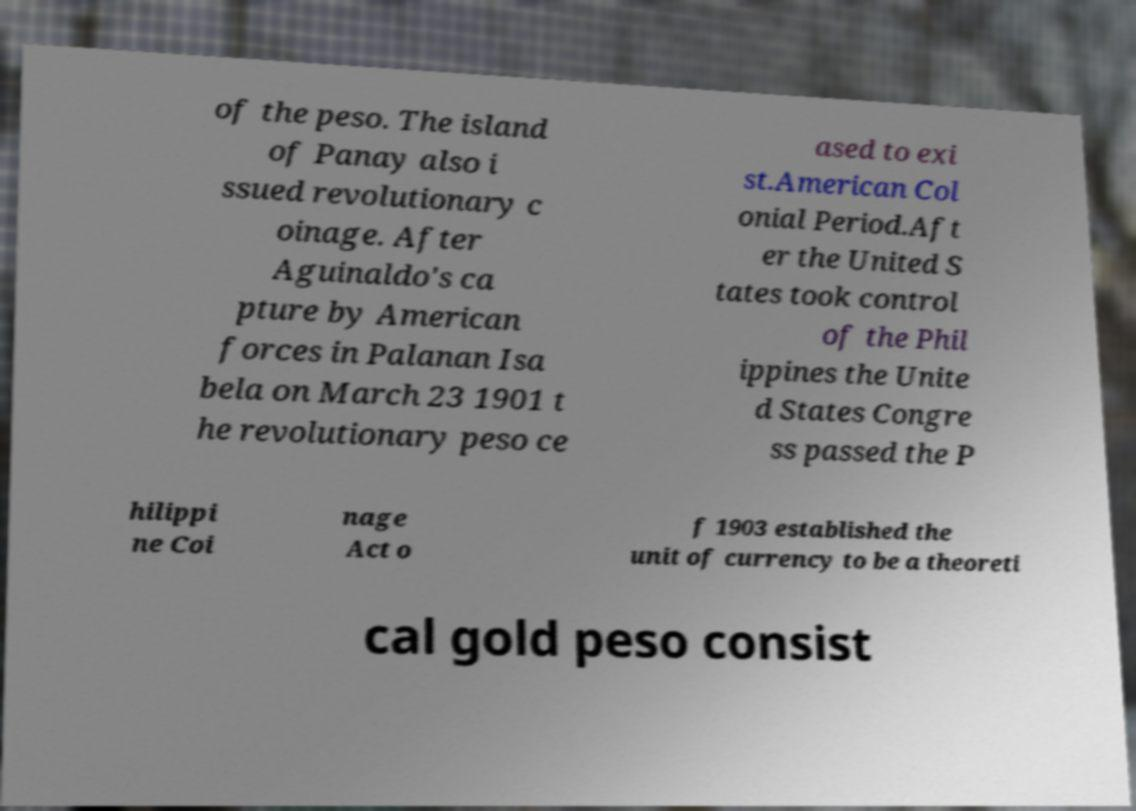Could you assist in decoding the text presented in this image and type it out clearly? of the peso. The island of Panay also i ssued revolutionary c oinage. After Aguinaldo's ca pture by American forces in Palanan Isa bela on March 23 1901 t he revolutionary peso ce ased to exi st.American Col onial Period.Aft er the United S tates took control of the Phil ippines the Unite d States Congre ss passed the P hilippi ne Coi nage Act o f 1903 established the unit of currency to be a theoreti cal gold peso consist 